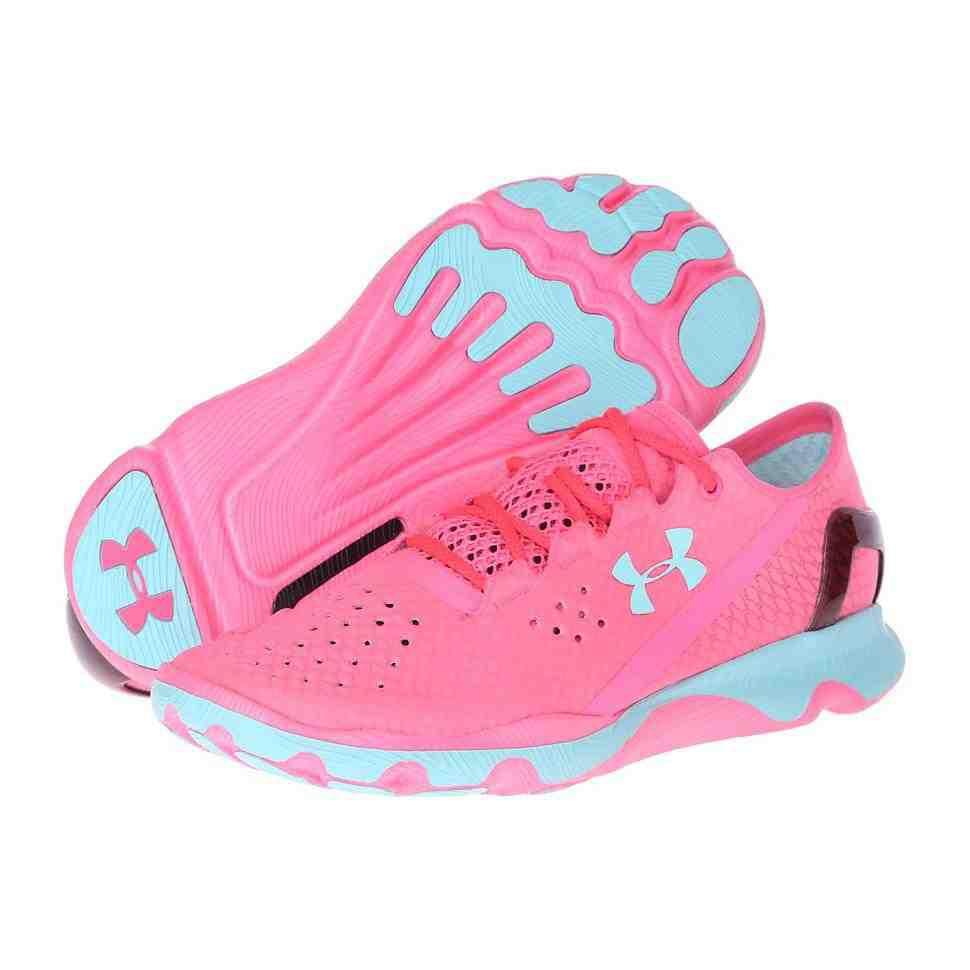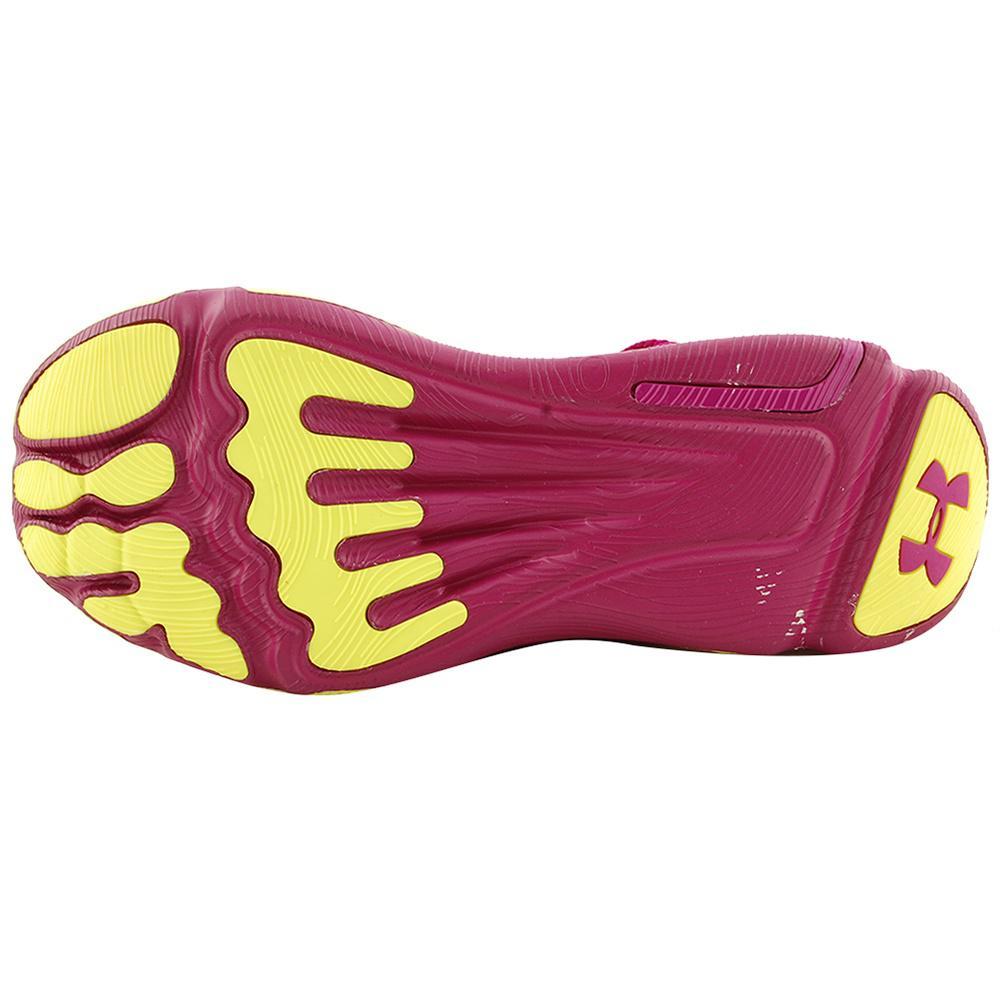The first image is the image on the left, the second image is the image on the right. Given the left and right images, does the statement "One of the images contains a pink and yellow shoe." hold true? Answer yes or no. Yes. The first image is the image on the left, the second image is the image on the right. Assess this claim about the two images: "There are three shoes.". Correct or not? Answer yes or no. Yes. 